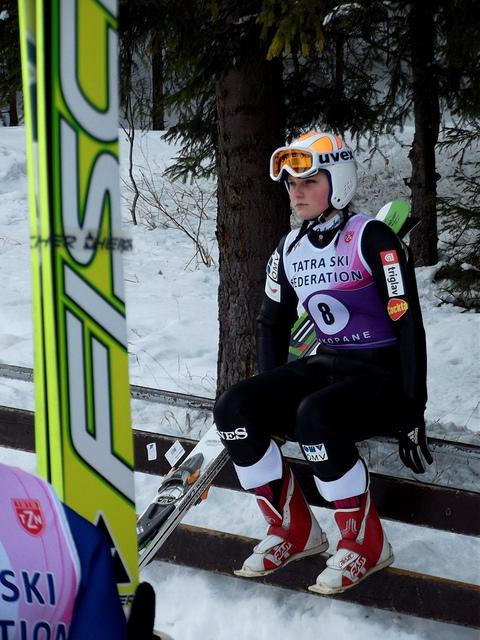What is the child wearing? Please explain your reasoning. goggles. These are to prevent snow blindness 